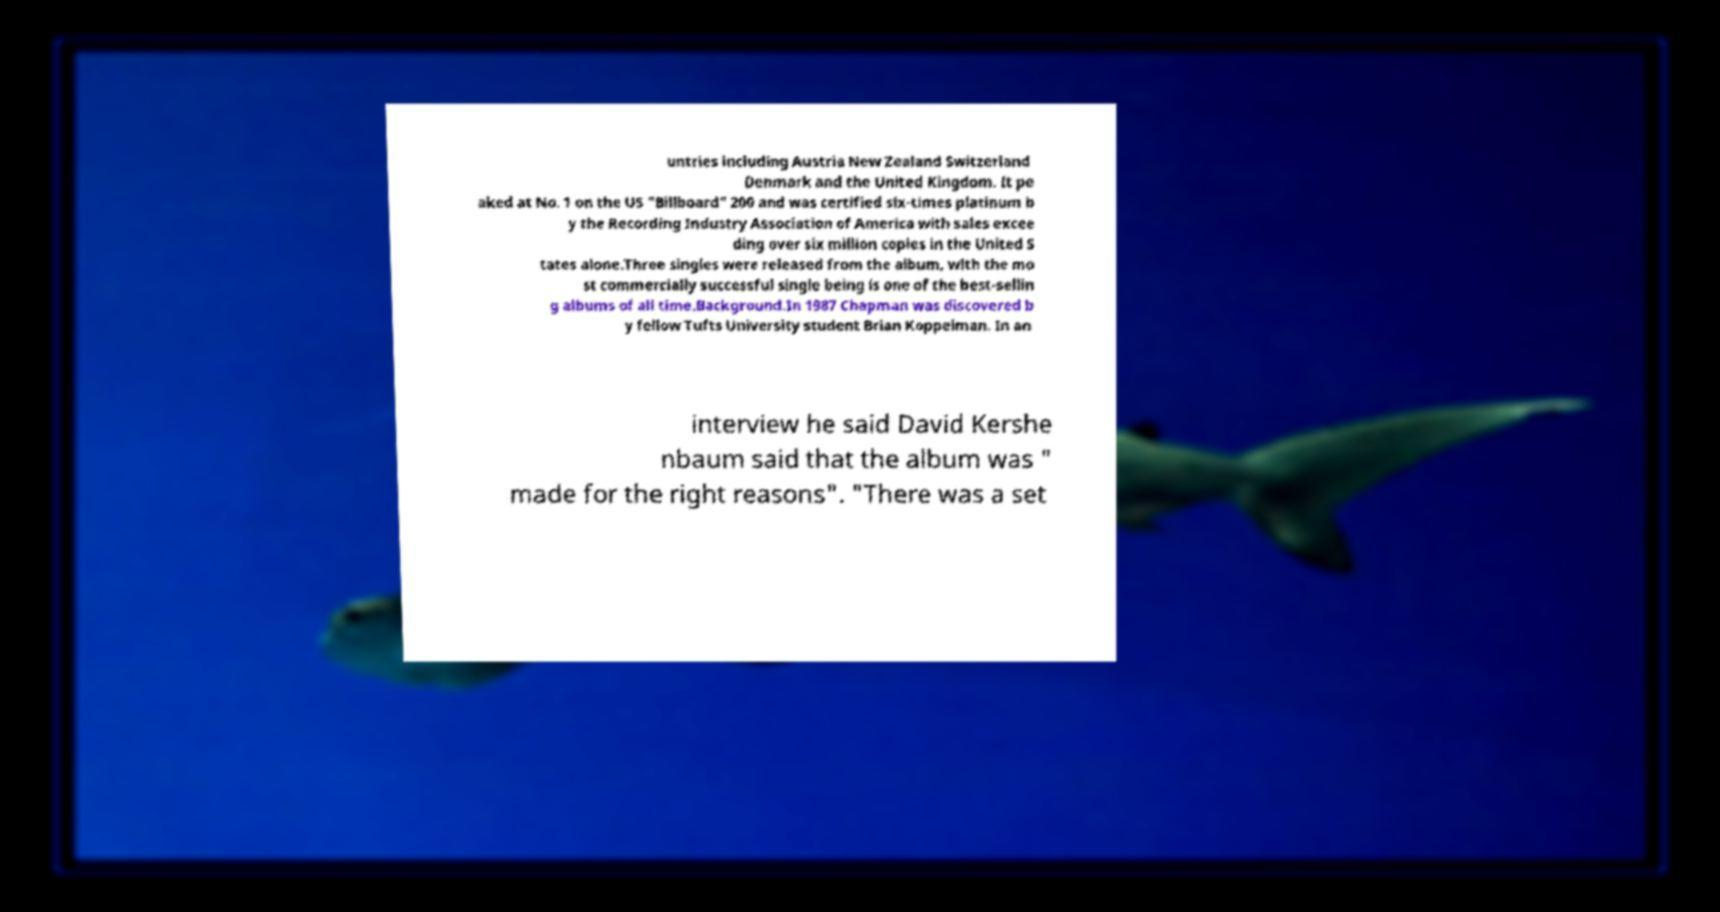Can you read and provide the text displayed in the image?This photo seems to have some interesting text. Can you extract and type it out for me? untries including Austria New Zealand Switzerland Denmark and the United Kingdom. It pe aked at No. 1 on the US "Billboard" 200 and was certified six-times platinum b y the Recording Industry Association of America with sales excee ding over six million copies in the United S tates alone.Three singles were released from the album, with the mo st commercially successful single being is one of the best-sellin g albums of all time.Background.In 1987 Chapman was discovered b y fellow Tufts University student Brian Koppelman. In an interview he said David Kershe nbaum said that the album was " made for the right reasons". "There was a set 